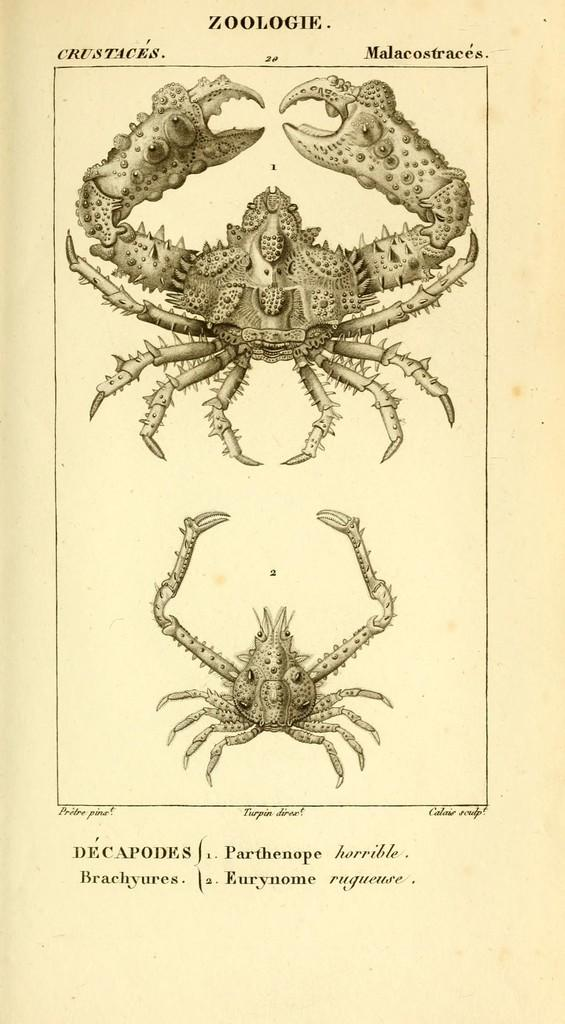What is the main subject of the image? The image contains a page from a book. What is depicted on the page? There are two Scorpios depicted on the page. Where can text be found on the page? There is text at the top of the page and text at the bottom of the page. What type of comb can be seen in the image? There is no comb present in the image; it features a page from a book with two Scorpios and text. What town is depicted in the image? There is no town depicted in the image; it features a page from a book with two Scorpios and text. 